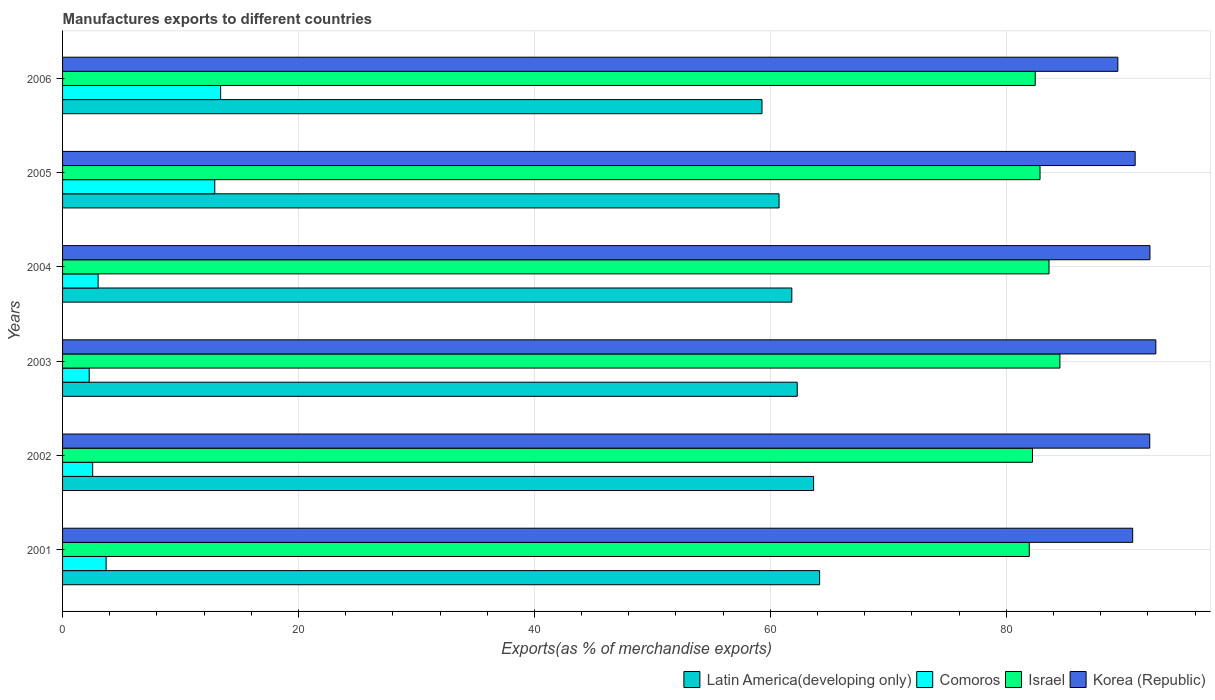How many different coloured bars are there?
Provide a succinct answer. 4. What is the label of the 3rd group of bars from the top?
Give a very brief answer. 2004. What is the percentage of exports to different countries in Israel in 2006?
Give a very brief answer. 82.45. Across all years, what is the maximum percentage of exports to different countries in Israel?
Your answer should be compact. 84.55. Across all years, what is the minimum percentage of exports to different countries in Comoros?
Provide a succinct answer. 2.26. In which year was the percentage of exports to different countries in Comoros maximum?
Provide a short and direct response. 2006. What is the total percentage of exports to different countries in Israel in the graph?
Offer a very short reply. 497.65. What is the difference between the percentage of exports to different countries in Comoros in 2002 and that in 2003?
Your answer should be very brief. 0.29. What is the difference between the percentage of exports to different countries in Korea (Republic) in 2004 and the percentage of exports to different countries in Comoros in 2003?
Offer a very short reply. 89.92. What is the average percentage of exports to different countries in Korea (Republic) per year?
Keep it short and to the point. 91.35. In the year 2004, what is the difference between the percentage of exports to different countries in Comoros and percentage of exports to different countries in Korea (Republic)?
Keep it short and to the point. -89.16. What is the ratio of the percentage of exports to different countries in Latin America(developing only) in 2001 to that in 2004?
Make the answer very short. 1.04. Is the difference between the percentage of exports to different countries in Comoros in 2001 and 2003 greater than the difference between the percentage of exports to different countries in Korea (Republic) in 2001 and 2003?
Give a very brief answer. Yes. What is the difference between the highest and the second highest percentage of exports to different countries in Latin America(developing only)?
Keep it short and to the point. 0.51. What is the difference between the highest and the lowest percentage of exports to different countries in Latin America(developing only)?
Offer a very short reply. 4.88. In how many years, is the percentage of exports to different countries in Israel greater than the average percentage of exports to different countries in Israel taken over all years?
Provide a succinct answer. 2. What does the 3rd bar from the top in 2005 represents?
Make the answer very short. Comoros. What does the 1st bar from the bottom in 2006 represents?
Your answer should be very brief. Latin America(developing only). Is it the case that in every year, the sum of the percentage of exports to different countries in Israel and percentage of exports to different countries in Comoros is greater than the percentage of exports to different countries in Latin America(developing only)?
Your response must be concise. Yes. How many bars are there?
Your answer should be compact. 24. How many years are there in the graph?
Your response must be concise. 6. What is the difference between two consecutive major ticks on the X-axis?
Make the answer very short. 20. Are the values on the major ticks of X-axis written in scientific E-notation?
Provide a succinct answer. No. Does the graph contain any zero values?
Offer a terse response. No. Does the graph contain grids?
Ensure brevity in your answer.  Yes. How are the legend labels stacked?
Your response must be concise. Horizontal. What is the title of the graph?
Provide a succinct answer. Manufactures exports to different countries. Does "Lebanon" appear as one of the legend labels in the graph?
Provide a short and direct response. No. What is the label or title of the X-axis?
Give a very brief answer. Exports(as % of merchandise exports). What is the label or title of the Y-axis?
Ensure brevity in your answer.  Years. What is the Exports(as % of merchandise exports) of Latin America(developing only) in 2001?
Your response must be concise. 64.18. What is the Exports(as % of merchandise exports) of Comoros in 2001?
Ensure brevity in your answer.  3.69. What is the Exports(as % of merchandise exports) of Israel in 2001?
Provide a succinct answer. 81.95. What is the Exports(as % of merchandise exports) of Korea (Republic) in 2001?
Your answer should be compact. 90.71. What is the Exports(as % of merchandise exports) of Latin America(developing only) in 2002?
Your answer should be very brief. 63.67. What is the Exports(as % of merchandise exports) in Comoros in 2002?
Make the answer very short. 2.55. What is the Exports(as % of merchandise exports) in Israel in 2002?
Give a very brief answer. 82.22. What is the Exports(as % of merchandise exports) in Korea (Republic) in 2002?
Offer a terse response. 92.16. What is the Exports(as % of merchandise exports) of Latin America(developing only) in 2003?
Offer a very short reply. 62.28. What is the Exports(as % of merchandise exports) in Comoros in 2003?
Provide a short and direct response. 2.26. What is the Exports(as % of merchandise exports) in Israel in 2003?
Give a very brief answer. 84.55. What is the Exports(as % of merchandise exports) of Korea (Republic) in 2003?
Your answer should be compact. 92.68. What is the Exports(as % of merchandise exports) of Latin America(developing only) in 2004?
Your answer should be compact. 61.82. What is the Exports(as % of merchandise exports) of Comoros in 2004?
Ensure brevity in your answer.  3.01. What is the Exports(as % of merchandise exports) in Israel in 2004?
Offer a very short reply. 83.62. What is the Exports(as % of merchandise exports) in Korea (Republic) in 2004?
Your answer should be very brief. 92.18. What is the Exports(as % of merchandise exports) in Latin America(developing only) in 2005?
Offer a very short reply. 60.74. What is the Exports(as % of merchandise exports) in Comoros in 2005?
Ensure brevity in your answer.  12.9. What is the Exports(as % of merchandise exports) of Israel in 2005?
Keep it short and to the point. 82.86. What is the Exports(as % of merchandise exports) of Korea (Republic) in 2005?
Your response must be concise. 90.92. What is the Exports(as % of merchandise exports) in Latin America(developing only) in 2006?
Your response must be concise. 59.29. What is the Exports(as % of merchandise exports) of Comoros in 2006?
Keep it short and to the point. 13.4. What is the Exports(as % of merchandise exports) of Israel in 2006?
Give a very brief answer. 82.45. What is the Exports(as % of merchandise exports) in Korea (Republic) in 2006?
Make the answer very short. 89.46. Across all years, what is the maximum Exports(as % of merchandise exports) in Latin America(developing only)?
Keep it short and to the point. 64.18. Across all years, what is the maximum Exports(as % of merchandise exports) of Comoros?
Provide a short and direct response. 13.4. Across all years, what is the maximum Exports(as % of merchandise exports) in Israel?
Give a very brief answer. 84.55. Across all years, what is the maximum Exports(as % of merchandise exports) of Korea (Republic)?
Give a very brief answer. 92.68. Across all years, what is the minimum Exports(as % of merchandise exports) in Latin America(developing only)?
Your answer should be very brief. 59.29. Across all years, what is the minimum Exports(as % of merchandise exports) of Comoros?
Provide a succinct answer. 2.26. Across all years, what is the minimum Exports(as % of merchandise exports) in Israel?
Your answer should be very brief. 81.95. Across all years, what is the minimum Exports(as % of merchandise exports) of Korea (Republic)?
Offer a very short reply. 89.46. What is the total Exports(as % of merchandise exports) in Latin America(developing only) in the graph?
Keep it short and to the point. 371.97. What is the total Exports(as % of merchandise exports) of Comoros in the graph?
Offer a very short reply. 37.82. What is the total Exports(as % of merchandise exports) in Israel in the graph?
Offer a terse response. 497.65. What is the total Exports(as % of merchandise exports) of Korea (Republic) in the graph?
Give a very brief answer. 548.11. What is the difference between the Exports(as % of merchandise exports) in Latin America(developing only) in 2001 and that in 2002?
Offer a terse response. 0.51. What is the difference between the Exports(as % of merchandise exports) of Comoros in 2001 and that in 2002?
Ensure brevity in your answer.  1.14. What is the difference between the Exports(as % of merchandise exports) in Israel in 2001 and that in 2002?
Your answer should be compact. -0.28. What is the difference between the Exports(as % of merchandise exports) in Korea (Republic) in 2001 and that in 2002?
Provide a short and direct response. -1.45. What is the difference between the Exports(as % of merchandise exports) in Latin America(developing only) in 2001 and that in 2003?
Give a very brief answer. 1.9. What is the difference between the Exports(as % of merchandise exports) in Comoros in 2001 and that in 2003?
Your answer should be very brief. 1.44. What is the difference between the Exports(as % of merchandise exports) in Israel in 2001 and that in 2003?
Offer a very short reply. -2.6. What is the difference between the Exports(as % of merchandise exports) of Korea (Republic) in 2001 and that in 2003?
Offer a very short reply. -1.96. What is the difference between the Exports(as % of merchandise exports) of Latin America(developing only) in 2001 and that in 2004?
Offer a very short reply. 2.36. What is the difference between the Exports(as % of merchandise exports) in Comoros in 2001 and that in 2004?
Offer a terse response. 0.68. What is the difference between the Exports(as % of merchandise exports) in Israel in 2001 and that in 2004?
Ensure brevity in your answer.  -1.68. What is the difference between the Exports(as % of merchandise exports) of Korea (Republic) in 2001 and that in 2004?
Provide a succinct answer. -1.46. What is the difference between the Exports(as % of merchandise exports) of Latin America(developing only) in 2001 and that in 2005?
Provide a short and direct response. 3.44. What is the difference between the Exports(as % of merchandise exports) of Comoros in 2001 and that in 2005?
Make the answer very short. -9.21. What is the difference between the Exports(as % of merchandise exports) of Israel in 2001 and that in 2005?
Keep it short and to the point. -0.91. What is the difference between the Exports(as % of merchandise exports) of Korea (Republic) in 2001 and that in 2005?
Provide a short and direct response. -0.21. What is the difference between the Exports(as % of merchandise exports) in Latin America(developing only) in 2001 and that in 2006?
Your response must be concise. 4.88. What is the difference between the Exports(as % of merchandise exports) of Comoros in 2001 and that in 2006?
Your response must be concise. -9.71. What is the difference between the Exports(as % of merchandise exports) in Israel in 2001 and that in 2006?
Make the answer very short. -0.51. What is the difference between the Exports(as % of merchandise exports) in Korea (Republic) in 2001 and that in 2006?
Ensure brevity in your answer.  1.26. What is the difference between the Exports(as % of merchandise exports) of Latin America(developing only) in 2002 and that in 2003?
Your answer should be very brief. 1.39. What is the difference between the Exports(as % of merchandise exports) of Comoros in 2002 and that in 2003?
Provide a short and direct response. 0.29. What is the difference between the Exports(as % of merchandise exports) of Israel in 2002 and that in 2003?
Your answer should be very brief. -2.32. What is the difference between the Exports(as % of merchandise exports) in Korea (Republic) in 2002 and that in 2003?
Your answer should be very brief. -0.52. What is the difference between the Exports(as % of merchandise exports) in Latin America(developing only) in 2002 and that in 2004?
Offer a very short reply. 1.85. What is the difference between the Exports(as % of merchandise exports) of Comoros in 2002 and that in 2004?
Keep it short and to the point. -0.46. What is the difference between the Exports(as % of merchandise exports) of Korea (Republic) in 2002 and that in 2004?
Offer a very short reply. -0.02. What is the difference between the Exports(as % of merchandise exports) in Latin America(developing only) in 2002 and that in 2005?
Your answer should be compact. 2.93. What is the difference between the Exports(as % of merchandise exports) in Comoros in 2002 and that in 2005?
Offer a very short reply. -10.35. What is the difference between the Exports(as % of merchandise exports) of Israel in 2002 and that in 2005?
Your answer should be very brief. -0.64. What is the difference between the Exports(as % of merchandise exports) in Korea (Republic) in 2002 and that in 2005?
Your answer should be compact. 1.24. What is the difference between the Exports(as % of merchandise exports) in Latin America(developing only) in 2002 and that in 2006?
Give a very brief answer. 4.38. What is the difference between the Exports(as % of merchandise exports) of Comoros in 2002 and that in 2006?
Your answer should be very brief. -10.85. What is the difference between the Exports(as % of merchandise exports) in Israel in 2002 and that in 2006?
Your answer should be very brief. -0.23. What is the difference between the Exports(as % of merchandise exports) in Korea (Republic) in 2002 and that in 2006?
Your answer should be very brief. 2.7. What is the difference between the Exports(as % of merchandise exports) of Latin America(developing only) in 2003 and that in 2004?
Provide a short and direct response. 0.46. What is the difference between the Exports(as % of merchandise exports) of Comoros in 2003 and that in 2004?
Your response must be concise. -0.76. What is the difference between the Exports(as % of merchandise exports) of Israel in 2003 and that in 2004?
Give a very brief answer. 0.92. What is the difference between the Exports(as % of merchandise exports) of Korea (Republic) in 2003 and that in 2004?
Your answer should be very brief. 0.5. What is the difference between the Exports(as % of merchandise exports) in Latin America(developing only) in 2003 and that in 2005?
Your answer should be very brief. 1.54. What is the difference between the Exports(as % of merchandise exports) in Comoros in 2003 and that in 2005?
Give a very brief answer. -10.64. What is the difference between the Exports(as % of merchandise exports) of Israel in 2003 and that in 2005?
Ensure brevity in your answer.  1.68. What is the difference between the Exports(as % of merchandise exports) of Korea (Republic) in 2003 and that in 2005?
Provide a short and direct response. 1.75. What is the difference between the Exports(as % of merchandise exports) of Latin America(developing only) in 2003 and that in 2006?
Your answer should be compact. 2.99. What is the difference between the Exports(as % of merchandise exports) of Comoros in 2003 and that in 2006?
Offer a terse response. -11.14. What is the difference between the Exports(as % of merchandise exports) in Israel in 2003 and that in 2006?
Offer a terse response. 2.09. What is the difference between the Exports(as % of merchandise exports) of Korea (Republic) in 2003 and that in 2006?
Ensure brevity in your answer.  3.22. What is the difference between the Exports(as % of merchandise exports) in Latin America(developing only) in 2004 and that in 2005?
Provide a succinct answer. 1.08. What is the difference between the Exports(as % of merchandise exports) in Comoros in 2004 and that in 2005?
Make the answer very short. -9.89. What is the difference between the Exports(as % of merchandise exports) in Israel in 2004 and that in 2005?
Your answer should be very brief. 0.76. What is the difference between the Exports(as % of merchandise exports) in Korea (Republic) in 2004 and that in 2005?
Provide a succinct answer. 1.25. What is the difference between the Exports(as % of merchandise exports) in Latin America(developing only) in 2004 and that in 2006?
Offer a very short reply. 2.53. What is the difference between the Exports(as % of merchandise exports) of Comoros in 2004 and that in 2006?
Offer a very short reply. -10.39. What is the difference between the Exports(as % of merchandise exports) in Israel in 2004 and that in 2006?
Your answer should be very brief. 1.17. What is the difference between the Exports(as % of merchandise exports) in Korea (Republic) in 2004 and that in 2006?
Offer a terse response. 2.72. What is the difference between the Exports(as % of merchandise exports) in Latin America(developing only) in 2005 and that in 2006?
Offer a very short reply. 1.45. What is the difference between the Exports(as % of merchandise exports) in Comoros in 2005 and that in 2006?
Your answer should be very brief. -0.5. What is the difference between the Exports(as % of merchandise exports) of Israel in 2005 and that in 2006?
Your response must be concise. 0.41. What is the difference between the Exports(as % of merchandise exports) of Korea (Republic) in 2005 and that in 2006?
Keep it short and to the point. 1.47. What is the difference between the Exports(as % of merchandise exports) of Latin America(developing only) in 2001 and the Exports(as % of merchandise exports) of Comoros in 2002?
Make the answer very short. 61.62. What is the difference between the Exports(as % of merchandise exports) in Latin America(developing only) in 2001 and the Exports(as % of merchandise exports) in Israel in 2002?
Your answer should be very brief. -18.05. What is the difference between the Exports(as % of merchandise exports) of Latin America(developing only) in 2001 and the Exports(as % of merchandise exports) of Korea (Republic) in 2002?
Your response must be concise. -27.98. What is the difference between the Exports(as % of merchandise exports) of Comoros in 2001 and the Exports(as % of merchandise exports) of Israel in 2002?
Your answer should be very brief. -78.53. What is the difference between the Exports(as % of merchandise exports) of Comoros in 2001 and the Exports(as % of merchandise exports) of Korea (Republic) in 2002?
Keep it short and to the point. -88.47. What is the difference between the Exports(as % of merchandise exports) in Israel in 2001 and the Exports(as % of merchandise exports) in Korea (Republic) in 2002?
Offer a very short reply. -10.21. What is the difference between the Exports(as % of merchandise exports) in Latin America(developing only) in 2001 and the Exports(as % of merchandise exports) in Comoros in 2003?
Provide a short and direct response. 61.92. What is the difference between the Exports(as % of merchandise exports) of Latin America(developing only) in 2001 and the Exports(as % of merchandise exports) of Israel in 2003?
Give a very brief answer. -20.37. What is the difference between the Exports(as % of merchandise exports) in Latin America(developing only) in 2001 and the Exports(as % of merchandise exports) in Korea (Republic) in 2003?
Ensure brevity in your answer.  -28.5. What is the difference between the Exports(as % of merchandise exports) in Comoros in 2001 and the Exports(as % of merchandise exports) in Israel in 2003?
Your answer should be compact. -80.85. What is the difference between the Exports(as % of merchandise exports) of Comoros in 2001 and the Exports(as % of merchandise exports) of Korea (Republic) in 2003?
Give a very brief answer. -88.98. What is the difference between the Exports(as % of merchandise exports) in Israel in 2001 and the Exports(as % of merchandise exports) in Korea (Republic) in 2003?
Your response must be concise. -10.73. What is the difference between the Exports(as % of merchandise exports) in Latin America(developing only) in 2001 and the Exports(as % of merchandise exports) in Comoros in 2004?
Offer a terse response. 61.16. What is the difference between the Exports(as % of merchandise exports) of Latin America(developing only) in 2001 and the Exports(as % of merchandise exports) of Israel in 2004?
Make the answer very short. -19.45. What is the difference between the Exports(as % of merchandise exports) in Latin America(developing only) in 2001 and the Exports(as % of merchandise exports) in Korea (Republic) in 2004?
Your answer should be very brief. -28. What is the difference between the Exports(as % of merchandise exports) of Comoros in 2001 and the Exports(as % of merchandise exports) of Israel in 2004?
Offer a very short reply. -79.93. What is the difference between the Exports(as % of merchandise exports) in Comoros in 2001 and the Exports(as % of merchandise exports) in Korea (Republic) in 2004?
Your answer should be very brief. -88.48. What is the difference between the Exports(as % of merchandise exports) of Israel in 2001 and the Exports(as % of merchandise exports) of Korea (Republic) in 2004?
Give a very brief answer. -10.23. What is the difference between the Exports(as % of merchandise exports) of Latin America(developing only) in 2001 and the Exports(as % of merchandise exports) of Comoros in 2005?
Keep it short and to the point. 51.27. What is the difference between the Exports(as % of merchandise exports) in Latin America(developing only) in 2001 and the Exports(as % of merchandise exports) in Israel in 2005?
Offer a terse response. -18.68. What is the difference between the Exports(as % of merchandise exports) in Latin America(developing only) in 2001 and the Exports(as % of merchandise exports) in Korea (Republic) in 2005?
Your answer should be compact. -26.75. What is the difference between the Exports(as % of merchandise exports) in Comoros in 2001 and the Exports(as % of merchandise exports) in Israel in 2005?
Your answer should be compact. -79.17. What is the difference between the Exports(as % of merchandise exports) of Comoros in 2001 and the Exports(as % of merchandise exports) of Korea (Republic) in 2005?
Provide a succinct answer. -87.23. What is the difference between the Exports(as % of merchandise exports) in Israel in 2001 and the Exports(as % of merchandise exports) in Korea (Republic) in 2005?
Ensure brevity in your answer.  -8.98. What is the difference between the Exports(as % of merchandise exports) in Latin America(developing only) in 2001 and the Exports(as % of merchandise exports) in Comoros in 2006?
Provide a succinct answer. 50.78. What is the difference between the Exports(as % of merchandise exports) of Latin America(developing only) in 2001 and the Exports(as % of merchandise exports) of Israel in 2006?
Your response must be concise. -18.28. What is the difference between the Exports(as % of merchandise exports) in Latin America(developing only) in 2001 and the Exports(as % of merchandise exports) in Korea (Republic) in 2006?
Provide a succinct answer. -25.28. What is the difference between the Exports(as % of merchandise exports) in Comoros in 2001 and the Exports(as % of merchandise exports) in Israel in 2006?
Keep it short and to the point. -78.76. What is the difference between the Exports(as % of merchandise exports) of Comoros in 2001 and the Exports(as % of merchandise exports) of Korea (Republic) in 2006?
Your answer should be compact. -85.76. What is the difference between the Exports(as % of merchandise exports) in Israel in 2001 and the Exports(as % of merchandise exports) in Korea (Republic) in 2006?
Your answer should be compact. -7.51. What is the difference between the Exports(as % of merchandise exports) in Latin America(developing only) in 2002 and the Exports(as % of merchandise exports) in Comoros in 2003?
Offer a very short reply. 61.41. What is the difference between the Exports(as % of merchandise exports) in Latin America(developing only) in 2002 and the Exports(as % of merchandise exports) in Israel in 2003?
Your answer should be very brief. -20.88. What is the difference between the Exports(as % of merchandise exports) in Latin America(developing only) in 2002 and the Exports(as % of merchandise exports) in Korea (Republic) in 2003?
Ensure brevity in your answer.  -29.01. What is the difference between the Exports(as % of merchandise exports) in Comoros in 2002 and the Exports(as % of merchandise exports) in Israel in 2003?
Your answer should be compact. -81.99. What is the difference between the Exports(as % of merchandise exports) of Comoros in 2002 and the Exports(as % of merchandise exports) of Korea (Republic) in 2003?
Offer a terse response. -90.12. What is the difference between the Exports(as % of merchandise exports) in Israel in 2002 and the Exports(as % of merchandise exports) in Korea (Republic) in 2003?
Your response must be concise. -10.45. What is the difference between the Exports(as % of merchandise exports) of Latin America(developing only) in 2002 and the Exports(as % of merchandise exports) of Comoros in 2004?
Offer a very short reply. 60.65. What is the difference between the Exports(as % of merchandise exports) in Latin America(developing only) in 2002 and the Exports(as % of merchandise exports) in Israel in 2004?
Keep it short and to the point. -19.96. What is the difference between the Exports(as % of merchandise exports) in Latin America(developing only) in 2002 and the Exports(as % of merchandise exports) in Korea (Republic) in 2004?
Give a very brief answer. -28.51. What is the difference between the Exports(as % of merchandise exports) in Comoros in 2002 and the Exports(as % of merchandise exports) in Israel in 2004?
Provide a short and direct response. -81.07. What is the difference between the Exports(as % of merchandise exports) in Comoros in 2002 and the Exports(as % of merchandise exports) in Korea (Republic) in 2004?
Ensure brevity in your answer.  -89.63. What is the difference between the Exports(as % of merchandise exports) of Israel in 2002 and the Exports(as % of merchandise exports) of Korea (Republic) in 2004?
Keep it short and to the point. -9.96. What is the difference between the Exports(as % of merchandise exports) in Latin America(developing only) in 2002 and the Exports(as % of merchandise exports) in Comoros in 2005?
Provide a succinct answer. 50.76. What is the difference between the Exports(as % of merchandise exports) of Latin America(developing only) in 2002 and the Exports(as % of merchandise exports) of Israel in 2005?
Provide a succinct answer. -19.19. What is the difference between the Exports(as % of merchandise exports) in Latin America(developing only) in 2002 and the Exports(as % of merchandise exports) in Korea (Republic) in 2005?
Keep it short and to the point. -27.26. What is the difference between the Exports(as % of merchandise exports) of Comoros in 2002 and the Exports(as % of merchandise exports) of Israel in 2005?
Your answer should be compact. -80.31. What is the difference between the Exports(as % of merchandise exports) of Comoros in 2002 and the Exports(as % of merchandise exports) of Korea (Republic) in 2005?
Your answer should be very brief. -88.37. What is the difference between the Exports(as % of merchandise exports) in Israel in 2002 and the Exports(as % of merchandise exports) in Korea (Republic) in 2005?
Provide a short and direct response. -8.7. What is the difference between the Exports(as % of merchandise exports) in Latin America(developing only) in 2002 and the Exports(as % of merchandise exports) in Comoros in 2006?
Offer a very short reply. 50.27. What is the difference between the Exports(as % of merchandise exports) of Latin America(developing only) in 2002 and the Exports(as % of merchandise exports) of Israel in 2006?
Provide a succinct answer. -18.79. What is the difference between the Exports(as % of merchandise exports) in Latin America(developing only) in 2002 and the Exports(as % of merchandise exports) in Korea (Republic) in 2006?
Offer a terse response. -25.79. What is the difference between the Exports(as % of merchandise exports) in Comoros in 2002 and the Exports(as % of merchandise exports) in Israel in 2006?
Provide a short and direct response. -79.9. What is the difference between the Exports(as % of merchandise exports) in Comoros in 2002 and the Exports(as % of merchandise exports) in Korea (Republic) in 2006?
Your answer should be compact. -86.9. What is the difference between the Exports(as % of merchandise exports) of Israel in 2002 and the Exports(as % of merchandise exports) of Korea (Republic) in 2006?
Your response must be concise. -7.24. What is the difference between the Exports(as % of merchandise exports) in Latin America(developing only) in 2003 and the Exports(as % of merchandise exports) in Comoros in 2004?
Make the answer very short. 59.26. What is the difference between the Exports(as % of merchandise exports) in Latin America(developing only) in 2003 and the Exports(as % of merchandise exports) in Israel in 2004?
Make the answer very short. -21.34. What is the difference between the Exports(as % of merchandise exports) in Latin America(developing only) in 2003 and the Exports(as % of merchandise exports) in Korea (Republic) in 2004?
Make the answer very short. -29.9. What is the difference between the Exports(as % of merchandise exports) in Comoros in 2003 and the Exports(as % of merchandise exports) in Israel in 2004?
Make the answer very short. -81.36. What is the difference between the Exports(as % of merchandise exports) in Comoros in 2003 and the Exports(as % of merchandise exports) in Korea (Republic) in 2004?
Your response must be concise. -89.92. What is the difference between the Exports(as % of merchandise exports) of Israel in 2003 and the Exports(as % of merchandise exports) of Korea (Republic) in 2004?
Give a very brief answer. -7.63. What is the difference between the Exports(as % of merchandise exports) in Latin America(developing only) in 2003 and the Exports(as % of merchandise exports) in Comoros in 2005?
Your answer should be compact. 49.37. What is the difference between the Exports(as % of merchandise exports) in Latin America(developing only) in 2003 and the Exports(as % of merchandise exports) in Israel in 2005?
Make the answer very short. -20.58. What is the difference between the Exports(as % of merchandise exports) of Latin America(developing only) in 2003 and the Exports(as % of merchandise exports) of Korea (Republic) in 2005?
Your answer should be compact. -28.65. What is the difference between the Exports(as % of merchandise exports) of Comoros in 2003 and the Exports(as % of merchandise exports) of Israel in 2005?
Your answer should be compact. -80.6. What is the difference between the Exports(as % of merchandise exports) in Comoros in 2003 and the Exports(as % of merchandise exports) in Korea (Republic) in 2005?
Your answer should be compact. -88.67. What is the difference between the Exports(as % of merchandise exports) of Israel in 2003 and the Exports(as % of merchandise exports) of Korea (Republic) in 2005?
Give a very brief answer. -6.38. What is the difference between the Exports(as % of merchandise exports) in Latin America(developing only) in 2003 and the Exports(as % of merchandise exports) in Comoros in 2006?
Make the answer very short. 48.88. What is the difference between the Exports(as % of merchandise exports) in Latin America(developing only) in 2003 and the Exports(as % of merchandise exports) in Israel in 2006?
Provide a succinct answer. -20.17. What is the difference between the Exports(as % of merchandise exports) in Latin America(developing only) in 2003 and the Exports(as % of merchandise exports) in Korea (Republic) in 2006?
Your response must be concise. -27.18. What is the difference between the Exports(as % of merchandise exports) of Comoros in 2003 and the Exports(as % of merchandise exports) of Israel in 2006?
Offer a very short reply. -80.19. What is the difference between the Exports(as % of merchandise exports) in Comoros in 2003 and the Exports(as % of merchandise exports) in Korea (Republic) in 2006?
Keep it short and to the point. -87.2. What is the difference between the Exports(as % of merchandise exports) in Israel in 2003 and the Exports(as % of merchandise exports) in Korea (Republic) in 2006?
Provide a short and direct response. -4.91. What is the difference between the Exports(as % of merchandise exports) in Latin America(developing only) in 2004 and the Exports(as % of merchandise exports) in Comoros in 2005?
Your response must be concise. 48.91. What is the difference between the Exports(as % of merchandise exports) in Latin America(developing only) in 2004 and the Exports(as % of merchandise exports) in Israel in 2005?
Ensure brevity in your answer.  -21.04. What is the difference between the Exports(as % of merchandise exports) of Latin America(developing only) in 2004 and the Exports(as % of merchandise exports) of Korea (Republic) in 2005?
Give a very brief answer. -29.11. What is the difference between the Exports(as % of merchandise exports) of Comoros in 2004 and the Exports(as % of merchandise exports) of Israel in 2005?
Ensure brevity in your answer.  -79.85. What is the difference between the Exports(as % of merchandise exports) of Comoros in 2004 and the Exports(as % of merchandise exports) of Korea (Republic) in 2005?
Your response must be concise. -87.91. What is the difference between the Exports(as % of merchandise exports) of Israel in 2004 and the Exports(as % of merchandise exports) of Korea (Republic) in 2005?
Make the answer very short. -7.3. What is the difference between the Exports(as % of merchandise exports) of Latin America(developing only) in 2004 and the Exports(as % of merchandise exports) of Comoros in 2006?
Offer a terse response. 48.42. What is the difference between the Exports(as % of merchandise exports) in Latin America(developing only) in 2004 and the Exports(as % of merchandise exports) in Israel in 2006?
Your answer should be compact. -20.63. What is the difference between the Exports(as % of merchandise exports) of Latin America(developing only) in 2004 and the Exports(as % of merchandise exports) of Korea (Republic) in 2006?
Your answer should be compact. -27.64. What is the difference between the Exports(as % of merchandise exports) in Comoros in 2004 and the Exports(as % of merchandise exports) in Israel in 2006?
Offer a terse response. -79.44. What is the difference between the Exports(as % of merchandise exports) of Comoros in 2004 and the Exports(as % of merchandise exports) of Korea (Republic) in 2006?
Offer a terse response. -86.44. What is the difference between the Exports(as % of merchandise exports) in Israel in 2004 and the Exports(as % of merchandise exports) in Korea (Republic) in 2006?
Ensure brevity in your answer.  -5.83. What is the difference between the Exports(as % of merchandise exports) in Latin America(developing only) in 2005 and the Exports(as % of merchandise exports) in Comoros in 2006?
Give a very brief answer. 47.34. What is the difference between the Exports(as % of merchandise exports) of Latin America(developing only) in 2005 and the Exports(as % of merchandise exports) of Israel in 2006?
Offer a very short reply. -21.71. What is the difference between the Exports(as % of merchandise exports) in Latin America(developing only) in 2005 and the Exports(as % of merchandise exports) in Korea (Republic) in 2006?
Your answer should be compact. -28.72. What is the difference between the Exports(as % of merchandise exports) of Comoros in 2005 and the Exports(as % of merchandise exports) of Israel in 2006?
Provide a short and direct response. -69.55. What is the difference between the Exports(as % of merchandise exports) of Comoros in 2005 and the Exports(as % of merchandise exports) of Korea (Republic) in 2006?
Provide a succinct answer. -76.55. What is the difference between the Exports(as % of merchandise exports) of Israel in 2005 and the Exports(as % of merchandise exports) of Korea (Republic) in 2006?
Provide a succinct answer. -6.6. What is the average Exports(as % of merchandise exports) in Latin America(developing only) per year?
Your answer should be compact. 61.99. What is the average Exports(as % of merchandise exports) in Comoros per year?
Keep it short and to the point. 6.3. What is the average Exports(as % of merchandise exports) of Israel per year?
Offer a very short reply. 82.94. What is the average Exports(as % of merchandise exports) in Korea (Republic) per year?
Provide a succinct answer. 91.35. In the year 2001, what is the difference between the Exports(as % of merchandise exports) in Latin America(developing only) and Exports(as % of merchandise exports) in Comoros?
Keep it short and to the point. 60.48. In the year 2001, what is the difference between the Exports(as % of merchandise exports) of Latin America(developing only) and Exports(as % of merchandise exports) of Israel?
Give a very brief answer. -17.77. In the year 2001, what is the difference between the Exports(as % of merchandise exports) in Latin America(developing only) and Exports(as % of merchandise exports) in Korea (Republic)?
Provide a short and direct response. -26.54. In the year 2001, what is the difference between the Exports(as % of merchandise exports) of Comoros and Exports(as % of merchandise exports) of Israel?
Provide a short and direct response. -78.25. In the year 2001, what is the difference between the Exports(as % of merchandise exports) in Comoros and Exports(as % of merchandise exports) in Korea (Republic)?
Make the answer very short. -87.02. In the year 2001, what is the difference between the Exports(as % of merchandise exports) in Israel and Exports(as % of merchandise exports) in Korea (Republic)?
Provide a short and direct response. -8.77. In the year 2002, what is the difference between the Exports(as % of merchandise exports) of Latin America(developing only) and Exports(as % of merchandise exports) of Comoros?
Keep it short and to the point. 61.11. In the year 2002, what is the difference between the Exports(as % of merchandise exports) in Latin America(developing only) and Exports(as % of merchandise exports) in Israel?
Provide a short and direct response. -18.56. In the year 2002, what is the difference between the Exports(as % of merchandise exports) of Latin America(developing only) and Exports(as % of merchandise exports) of Korea (Republic)?
Keep it short and to the point. -28.49. In the year 2002, what is the difference between the Exports(as % of merchandise exports) of Comoros and Exports(as % of merchandise exports) of Israel?
Keep it short and to the point. -79.67. In the year 2002, what is the difference between the Exports(as % of merchandise exports) in Comoros and Exports(as % of merchandise exports) in Korea (Republic)?
Keep it short and to the point. -89.61. In the year 2002, what is the difference between the Exports(as % of merchandise exports) of Israel and Exports(as % of merchandise exports) of Korea (Republic)?
Ensure brevity in your answer.  -9.94. In the year 2003, what is the difference between the Exports(as % of merchandise exports) of Latin America(developing only) and Exports(as % of merchandise exports) of Comoros?
Make the answer very short. 60.02. In the year 2003, what is the difference between the Exports(as % of merchandise exports) of Latin America(developing only) and Exports(as % of merchandise exports) of Israel?
Provide a short and direct response. -22.27. In the year 2003, what is the difference between the Exports(as % of merchandise exports) in Latin America(developing only) and Exports(as % of merchandise exports) in Korea (Republic)?
Provide a succinct answer. -30.4. In the year 2003, what is the difference between the Exports(as % of merchandise exports) in Comoros and Exports(as % of merchandise exports) in Israel?
Give a very brief answer. -82.29. In the year 2003, what is the difference between the Exports(as % of merchandise exports) of Comoros and Exports(as % of merchandise exports) of Korea (Republic)?
Provide a short and direct response. -90.42. In the year 2003, what is the difference between the Exports(as % of merchandise exports) in Israel and Exports(as % of merchandise exports) in Korea (Republic)?
Provide a succinct answer. -8.13. In the year 2004, what is the difference between the Exports(as % of merchandise exports) of Latin America(developing only) and Exports(as % of merchandise exports) of Comoros?
Your answer should be compact. 58.8. In the year 2004, what is the difference between the Exports(as % of merchandise exports) of Latin America(developing only) and Exports(as % of merchandise exports) of Israel?
Offer a very short reply. -21.8. In the year 2004, what is the difference between the Exports(as % of merchandise exports) in Latin America(developing only) and Exports(as % of merchandise exports) in Korea (Republic)?
Offer a very short reply. -30.36. In the year 2004, what is the difference between the Exports(as % of merchandise exports) in Comoros and Exports(as % of merchandise exports) in Israel?
Your answer should be compact. -80.61. In the year 2004, what is the difference between the Exports(as % of merchandise exports) of Comoros and Exports(as % of merchandise exports) of Korea (Republic)?
Offer a terse response. -89.16. In the year 2004, what is the difference between the Exports(as % of merchandise exports) of Israel and Exports(as % of merchandise exports) of Korea (Republic)?
Offer a terse response. -8.56. In the year 2005, what is the difference between the Exports(as % of merchandise exports) in Latin America(developing only) and Exports(as % of merchandise exports) in Comoros?
Offer a terse response. 47.83. In the year 2005, what is the difference between the Exports(as % of merchandise exports) in Latin America(developing only) and Exports(as % of merchandise exports) in Israel?
Your answer should be compact. -22.12. In the year 2005, what is the difference between the Exports(as % of merchandise exports) in Latin America(developing only) and Exports(as % of merchandise exports) in Korea (Republic)?
Offer a very short reply. -30.19. In the year 2005, what is the difference between the Exports(as % of merchandise exports) in Comoros and Exports(as % of merchandise exports) in Israel?
Your response must be concise. -69.96. In the year 2005, what is the difference between the Exports(as % of merchandise exports) in Comoros and Exports(as % of merchandise exports) in Korea (Republic)?
Ensure brevity in your answer.  -78.02. In the year 2005, what is the difference between the Exports(as % of merchandise exports) of Israel and Exports(as % of merchandise exports) of Korea (Republic)?
Offer a very short reply. -8.06. In the year 2006, what is the difference between the Exports(as % of merchandise exports) in Latin America(developing only) and Exports(as % of merchandise exports) in Comoros?
Ensure brevity in your answer.  45.89. In the year 2006, what is the difference between the Exports(as % of merchandise exports) of Latin America(developing only) and Exports(as % of merchandise exports) of Israel?
Make the answer very short. -23.16. In the year 2006, what is the difference between the Exports(as % of merchandise exports) of Latin America(developing only) and Exports(as % of merchandise exports) of Korea (Republic)?
Provide a short and direct response. -30.17. In the year 2006, what is the difference between the Exports(as % of merchandise exports) of Comoros and Exports(as % of merchandise exports) of Israel?
Provide a succinct answer. -69.05. In the year 2006, what is the difference between the Exports(as % of merchandise exports) in Comoros and Exports(as % of merchandise exports) in Korea (Republic)?
Your answer should be very brief. -76.06. In the year 2006, what is the difference between the Exports(as % of merchandise exports) in Israel and Exports(as % of merchandise exports) in Korea (Republic)?
Provide a short and direct response. -7.01. What is the ratio of the Exports(as % of merchandise exports) in Comoros in 2001 to that in 2002?
Offer a terse response. 1.45. What is the ratio of the Exports(as % of merchandise exports) in Korea (Republic) in 2001 to that in 2002?
Provide a short and direct response. 0.98. What is the ratio of the Exports(as % of merchandise exports) of Latin America(developing only) in 2001 to that in 2003?
Provide a short and direct response. 1.03. What is the ratio of the Exports(as % of merchandise exports) of Comoros in 2001 to that in 2003?
Keep it short and to the point. 1.64. What is the ratio of the Exports(as % of merchandise exports) of Israel in 2001 to that in 2003?
Keep it short and to the point. 0.97. What is the ratio of the Exports(as % of merchandise exports) of Korea (Republic) in 2001 to that in 2003?
Make the answer very short. 0.98. What is the ratio of the Exports(as % of merchandise exports) in Latin America(developing only) in 2001 to that in 2004?
Ensure brevity in your answer.  1.04. What is the ratio of the Exports(as % of merchandise exports) of Comoros in 2001 to that in 2004?
Your answer should be compact. 1.23. What is the ratio of the Exports(as % of merchandise exports) in Korea (Republic) in 2001 to that in 2004?
Make the answer very short. 0.98. What is the ratio of the Exports(as % of merchandise exports) in Latin America(developing only) in 2001 to that in 2005?
Make the answer very short. 1.06. What is the ratio of the Exports(as % of merchandise exports) in Comoros in 2001 to that in 2005?
Offer a terse response. 0.29. What is the ratio of the Exports(as % of merchandise exports) of Korea (Republic) in 2001 to that in 2005?
Provide a succinct answer. 1. What is the ratio of the Exports(as % of merchandise exports) in Latin America(developing only) in 2001 to that in 2006?
Offer a very short reply. 1.08. What is the ratio of the Exports(as % of merchandise exports) of Comoros in 2001 to that in 2006?
Make the answer very short. 0.28. What is the ratio of the Exports(as % of merchandise exports) of Latin America(developing only) in 2002 to that in 2003?
Your answer should be compact. 1.02. What is the ratio of the Exports(as % of merchandise exports) of Comoros in 2002 to that in 2003?
Provide a succinct answer. 1.13. What is the ratio of the Exports(as % of merchandise exports) in Israel in 2002 to that in 2003?
Give a very brief answer. 0.97. What is the ratio of the Exports(as % of merchandise exports) of Korea (Republic) in 2002 to that in 2003?
Keep it short and to the point. 0.99. What is the ratio of the Exports(as % of merchandise exports) of Latin America(developing only) in 2002 to that in 2004?
Give a very brief answer. 1.03. What is the ratio of the Exports(as % of merchandise exports) of Comoros in 2002 to that in 2004?
Ensure brevity in your answer.  0.85. What is the ratio of the Exports(as % of merchandise exports) in Israel in 2002 to that in 2004?
Provide a succinct answer. 0.98. What is the ratio of the Exports(as % of merchandise exports) in Korea (Republic) in 2002 to that in 2004?
Your response must be concise. 1. What is the ratio of the Exports(as % of merchandise exports) in Latin America(developing only) in 2002 to that in 2005?
Provide a succinct answer. 1.05. What is the ratio of the Exports(as % of merchandise exports) of Comoros in 2002 to that in 2005?
Your response must be concise. 0.2. What is the ratio of the Exports(as % of merchandise exports) of Korea (Republic) in 2002 to that in 2005?
Ensure brevity in your answer.  1.01. What is the ratio of the Exports(as % of merchandise exports) of Latin America(developing only) in 2002 to that in 2006?
Keep it short and to the point. 1.07. What is the ratio of the Exports(as % of merchandise exports) of Comoros in 2002 to that in 2006?
Offer a terse response. 0.19. What is the ratio of the Exports(as % of merchandise exports) in Israel in 2002 to that in 2006?
Offer a terse response. 1. What is the ratio of the Exports(as % of merchandise exports) of Korea (Republic) in 2002 to that in 2006?
Your response must be concise. 1.03. What is the ratio of the Exports(as % of merchandise exports) in Latin America(developing only) in 2003 to that in 2004?
Keep it short and to the point. 1.01. What is the ratio of the Exports(as % of merchandise exports) of Comoros in 2003 to that in 2004?
Give a very brief answer. 0.75. What is the ratio of the Exports(as % of merchandise exports) in Israel in 2003 to that in 2004?
Ensure brevity in your answer.  1.01. What is the ratio of the Exports(as % of merchandise exports) in Korea (Republic) in 2003 to that in 2004?
Offer a very short reply. 1.01. What is the ratio of the Exports(as % of merchandise exports) in Latin America(developing only) in 2003 to that in 2005?
Your answer should be very brief. 1.03. What is the ratio of the Exports(as % of merchandise exports) in Comoros in 2003 to that in 2005?
Your answer should be compact. 0.17. What is the ratio of the Exports(as % of merchandise exports) of Israel in 2003 to that in 2005?
Provide a succinct answer. 1.02. What is the ratio of the Exports(as % of merchandise exports) in Korea (Republic) in 2003 to that in 2005?
Your answer should be very brief. 1.02. What is the ratio of the Exports(as % of merchandise exports) of Latin America(developing only) in 2003 to that in 2006?
Keep it short and to the point. 1.05. What is the ratio of the Exports(as % of merchandise exports) in Comoros in 2003 to that in 2006?
Make the answer very short. 0.17. What is the ratio of the Exports(as % of merchandise exports) in Israel in 2003 to that in 2006?
Your answer should be very brief. 1.03. What is the ratio of the Exports(as % of merchandise exports) in Korea (Republic) in 2003 to that in 2006?
Give a very brief answer. 1.04. What is the ratio of the Exports(as % of merchandise exports) in Latin America(developing only) in 2004 to that in 2005?
Offer a terse response. 1.02. What is the ratio of the Exports(as % of merchandise exports) in Comoros in 2004 to that in 2005?
Make the answer very short. 0.23. What is the ratio of the Exports(as % of merchandise exports) of Israel in 2004 to that in 2005?
Provide a succinct answer. 1.01. What is the ratio of the Exports(as % of merchandise exports) of Korea (Republic) in 2004 to that in 2005?
Offer a very short reply. 1.01. What is the ratio of the Exports(as % of merchandise exports) of Latin America(developing only) in 2004 to that in 2006?
Your answer should be very brief. 1.04. What is the ratio of the Exports(as % of merchandise exports) of Comoros in 2004 to that in 2006?
Your answer should be compact. 0.22. What is the ratio of the Exports(as % of merchandise exports) in Israel in 2004 to that in 2006?
Provide a succinct answer. 1.01. What is the ratio of the Exports(as % of merchandise exports) of Korea (Republic) in 2004 to that in 2006?
Provide a short and direct response. 1.03. What is the ratio of the Exports(as % of merchandise exports) in Latin America(developing only) in 2005 to that in 2006?
Make the answer very short. 1.02. What is the ratio of the Exports(as % of merchandise exports) in Comoros in 2005 to that in 2006?
Your answer should be very brief. 0.96. What is the ratio of the Exports(as % of merchandise exports) in Korea (Republic) in 2005 to that in 2006?
Your answer should be very brief. 1.02. What is the difference between the highest and the second highest Exports(as % of merchandise exports) of Latin America(developing only)?
Your response must be concise. 0.51. What is the difference between the highest and the second highest Exports(as % of merchandise exports) of Comoros?
Offer a very short reply. 0.5. What is the difference between the highest and the second highest Exports(as % of merchandise exports) in Israel?
Your response must be concise. 0.92. What is the difference between the highest and the second highest Exports(as % of merchandise exports) in Korea (Republic)?
Offer a very short reply. 0.5. What is the difference between the highest and the lowest Exports(as % of merchandise exports) of Latin America(developing only)?
Keep it short and to the point. 4.88. What is the difference between the highest and the lowest Exports(as % of merchandise exports) of Comoros?
Ensure brevity in your answer.  11.14. What is the difference between the highest and the lowest Exports(as % of merchandise exports) in Israel?
Provide a succinct answer. 2.6. What is the difference between the highest and the lowest Exports(as % of merchandise exports) of Korea (Republic)?
Your response must be concise. 3.22. 